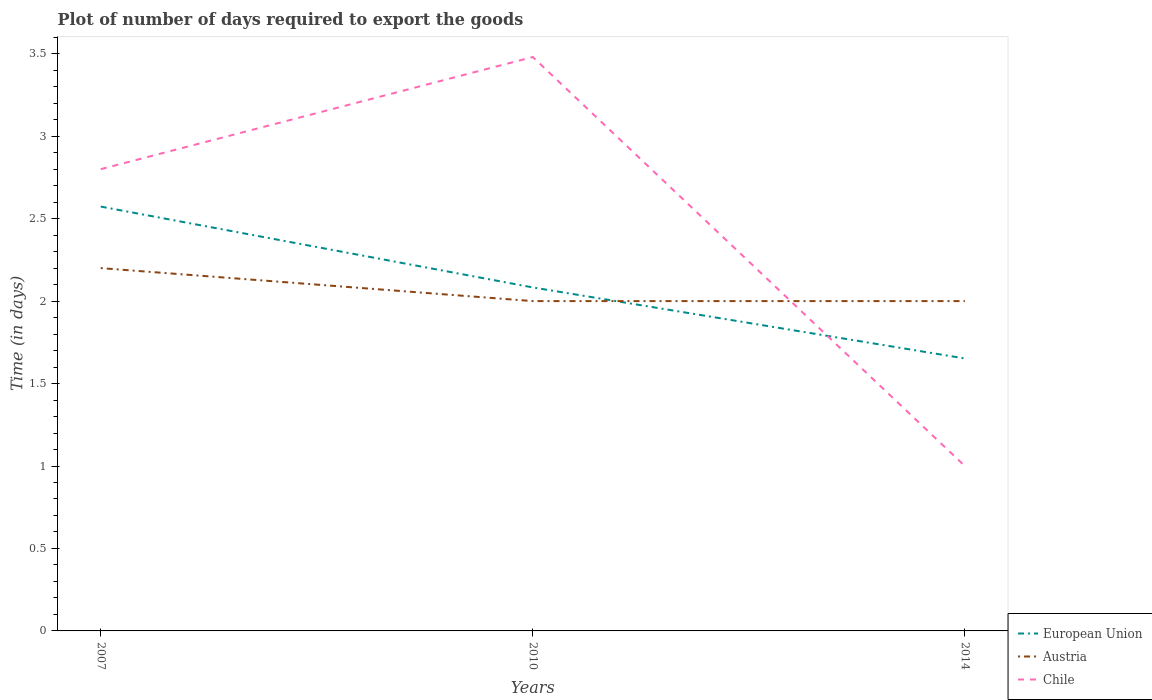Does the line corresponding to Chile intersect with the line corresponding to Austria?
Offer a terse response. Yes. In which year was the time required to export goods in European Union maximum?
Make the answer very short. 2014. What is the total time required to export goods in European Union in the graph?
Your answer should be very brief. 0.92. What is the difference between the highest and the second highest time required to export goods in Chile?
Provide a short and direct response. 2.48. How many lines are there?
Your answer should be very brief. 3. How many years are there in the graph?
Your answer should be compact. 3. Where does the legend appear in the graph?
Offer a terse response. Bottom right. How are the legend labels stacked?
Provide a short and direct response. Vertical. What is the title of the graph?
Your answer should be compact. Plot of number of days required to export the goods. Does "Marshall Islands" appear as one of the legend labels in the graph?
Provide a succinct answer. No. What is the label or title of the X-axis?
Provide a succinct answer. Years. What is the label or title of the Y-axis?
Offer a terse response. Time (in days). What is the Time (in days) of European Union in 2007?
Provide a succinct answer. 2.57. What is the Time (in days) in Austria in 2007?
Offer a very short reply. 2.2. What is the Time (in days) of European Union in 2010?
Provide a short and direct response. 2.08. What is the Time (in days) in Chile in 2010?
Offer a terse response. 3.48. What is the Time (in days) of European Union in 2014?
Give a very brief answer. 1.65. What is the Time (in days) in Austria in 2014?
Make the answer very short. 2. What is the Time (in days) in Chile in 2014?
Offer a terse response. 1. Across all years, what is the maximum Time (in days) in European Union?
Offer a terse response. 2.57. Across all years, what is the maximum Time (in days) of Chile?
Offer a terse response. 3.48. Across all years, what is the minimum Time (in days) in European Union?
Your answer should be compact. 1.65. What is the total Time (in days) of European Union in the graph?
Give a very brief answer. 6.31. What is the total Time (in days) in Chile in the graph?
Provide a short and direct response. 7.28. What is the difference between the Time (in days) of European Union in 2007 and that in 2010?
Offer a terse response. 0.49. What is the difference between the Time (in days) in Chile in 2007 and that in 2010?
Provide a succinct answer. -0.68. What is the difference between the Time (in days) of European Union in 2007 and that in 2014?
Your answer should be compact. 0.92. What is the difference between the Time (in days) of European Union in 2010 and that in 2014?
Offer a very short reply. 0.43. What is the difference between the Time (in days) in Chile in 2010 and that in 2014?
Provide a succinct answer. 2.48. What is the difference between the Time (in days) of European Union in 2007 and the Time (in days) of Austria in 2010?
Offer a very short reply. 0.57. What is the difference between the Time (in days) in European Union in 2007 and the Time (in days) in Chile in 2010?
Ensure brevity in your answer.  -0.91. What is the difference between the Time (in days) in Austria in 2007 and the Time (in days) in Chile in 2010?
Provide a short and direct response. -1.28. What is the difference between the Time (in days) in European Union in 2007 and the Time (in days) in Austria in 2014?
Your response must be concise. 0.57. What is the difference between the Time (in days) in European Union in 2007 and the Time (in days) in Chile in 2014?
Keep it short and to the point. 1.57. What is the difference between the Time (in days) in Austria in 2007 and the Time (in days) in Chile in 2014?
Your response must be concise. 1.2. What is the difference between the Time (in days) of European Union in 2010 and the Time (in days) of Austria in 2014?
Provide a succinct answer. 0.08. What is the difference between the Time (in days) of European Union in 2010 and the Time (in days) of Chile in 2014?
Keep it short and to the point. 1.08. What is the difference between the Time (in days) of Austria in 2010 and the Time (in days) of Chile in 2014?
Keep it short and to the point. 1. What is the average Time (in days) of European Union per year?
Make the answer very short. 2.1. What is the average Time (in days) in Austria per year?
Offer a very short reply. 2.07. What is the average Time (in days) in Chile per year?
Offer a terse response. 2.43. In the year 2007, what is the difference between the Time (in days) of European Union and Time (in days) of Austria?
Provide a short and direct response. 0.37. In the year 2007, what is the difference between the Time (in days) in European Union and Time (in days) in Chile?
Ensure brevity in your answer.  -0.23. In the year 2010, what is the difference between the Time (in days) in European Union and Time (in days) in Austria?
Your response must be concise. 0.08. In the year 2010, what is the difference between the Time (in days) of European Union and Time (in days) of Chile?
Provide a succinct answer. -1.4. In the year 2010, what is the difference between the Time (in days) in Austria and Time (in days) in Chile?
Offer a terse response. -1.48. In the year 2014, what is the difference between the Time (in days) of European Union and Time (in days) of Austria?
Provide a short and direct response. -0.35. In the year 2014, what is the difference between the Time (in days) in European Union and Time (in days) in Chile?
Provide a succinct answer. 0.65. What is the ratio of the Time (in days) of European Union in 2007 to that in 2010?
Make the answer very short. 1.24. What is the ratio of the Time (in days) of Austria in 2007 to that in 2010?
Keep it short and to the point. 1.1. What is the ratio of the Time (in days) of Chile in 2007 to that in 2010?
Offer a very short reply. 0.8. What is the ratio of the Time (in days) of European Union in 2007 to that in 2014?
Offer a terse response. 1.56. What is the ratio of the Time (in days) in Chile in 2007 to that in 2014?
Your answer should be very brief. 2.8. What is the ratio of the Time (in days) of European Union in 2010 to that in 2014?
Your answer should be very brief. 1.26. What is the ratio of the Time (in days) of Chile in 2010 to that in 2014?
Ensure brevity in your answer.  3.48. What is the difference between the highest and the second highest Time (in days) in European Union?
Your answer should be very brief. 0.49. What is the difference between the highest and the second highest Time (in days) of Chile?
Give a very brief answer. 0.68. What is the difference between the highest and the lowest Time (in days) of European Union?
Offer a terse response. 0.92. What is the difference between the highest and the lowest Time (in days) of Chile?
Your answer should be very brief. 2.48. 